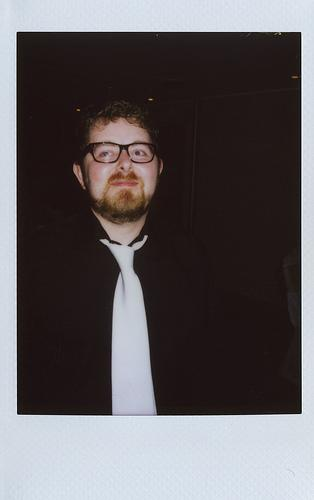Question: what is the predominant color of this picture?
Choices:
A. White.
B. Navy blue.
C. Black.
D. Grey.
Answer with the letter. Answer: C Question: what color is the man's tie?
Choices:
A. Black.
B. White.
C. Blue.
D. Red.
Answer with the letter. Answer: B Question: how many people are in this picture?
Choices:
A. Two.
B. One.
C. Three.
D. Four.
Answer with the letter. Answer: B Question: who is the subject of the picture?
Choices:
A. The lady with blond hair.
B. Man with glasses.
C. The boy holding a dog.
D. The little girl in green.
Answer with the letter. Answer: B Question: where are the glasses?
Choices:
A. On his head.
B. On the table.
C. Man's face.
D. On the desk.
Answer with the letter. Answer: C 